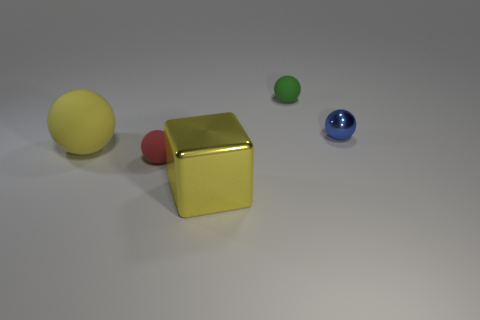Add 1 green matte balls. How many objects exist? 6 Subtract all spheres. How many objects are left? 1 Add 2 tiny purple cubes. How many tiny purple cubes exist? 2 Subtract 0 brown spheres. How many objects are left? 5 Subtract all small cyan objects. Subtract all big rubber spheres. How many objects are left? 4 Add 3 green matte spheres. How many green matte spheres are left? 4 